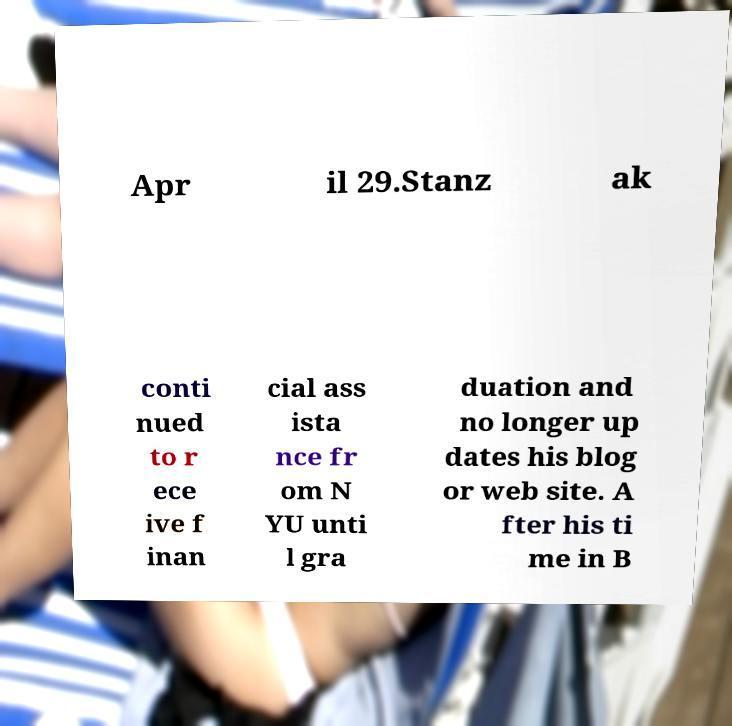Can you read and provide the text displayed in the image?This photo seems to have some interesting text. Can you extract and type it out for me? Apr il 29.Stanz ak conti nued to r ece ive f inan cial ass ista nce fr om N YU unti l gra duation and no longer up dates his blog or web site. A fter his ti me in B 